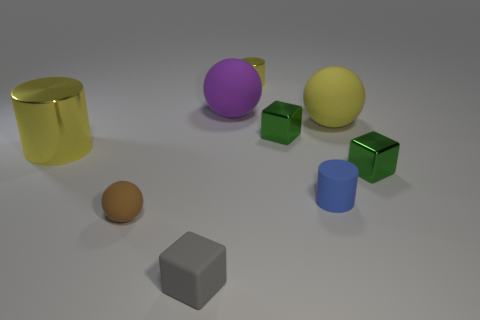Add 1 blue rubber cylinders. How many objects exist? 10 Subtract all blocks. How many objects are left? 6 Add 7 big spheres. How many big spheres are left? 9 Add 1 tiny purple shiny spheres. How many tiny purple shiny spheres exist? 1 Subtract 0 cyan balls. How many objects are left? 9 Subtract all tiny green cubes. Subtract all tiny yellow shiny objects. How many objects are left? 6 